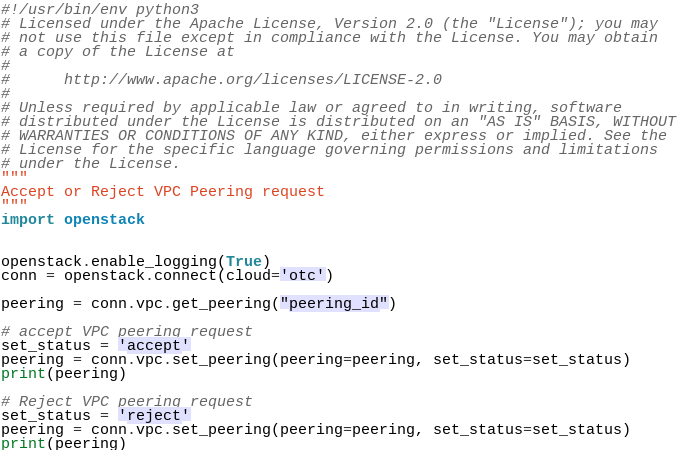Convert code to text. <code><loc_0><loc_0><loc_500><loc_500><_Python_>#!/usr/bin/env python3
# Licensed under the Apache License, Version 2.0 (the "License"); you may
# not use this file except in compliance with the License. You may obtain
# a copy of the License at
#
#      http://www.apache.org/licenses/LICENSE-2.0
#
# Unless required by applicable law or agreed to in writing, software
# distributed under the License is distributed on an "AS IS" BASIS, WITHOUT
# WARRANTIES OR CONDITIONS OF ANY KIND, either express or implied. See the
# License for the specific language governing permissions and limitations
# under the License.
"""
Accept or Reject VPC Peering request
"""
import openstack


openstack.enable_logging(True)
conn = openstack.connect(cloud='otc')

peering = conn.vpc.get_peering("peering_id")

# accept VPC peering request
set_status = 'accept'
peering = conn.vpc.set_peering(peering=peering, set_status=set_status)
print(peering)

# Reject VPC peering request
set_status = 'reject'
peering = conn.vpc.set_peering(peering=peering, set_status=set_status)
print(peering)
</code> 